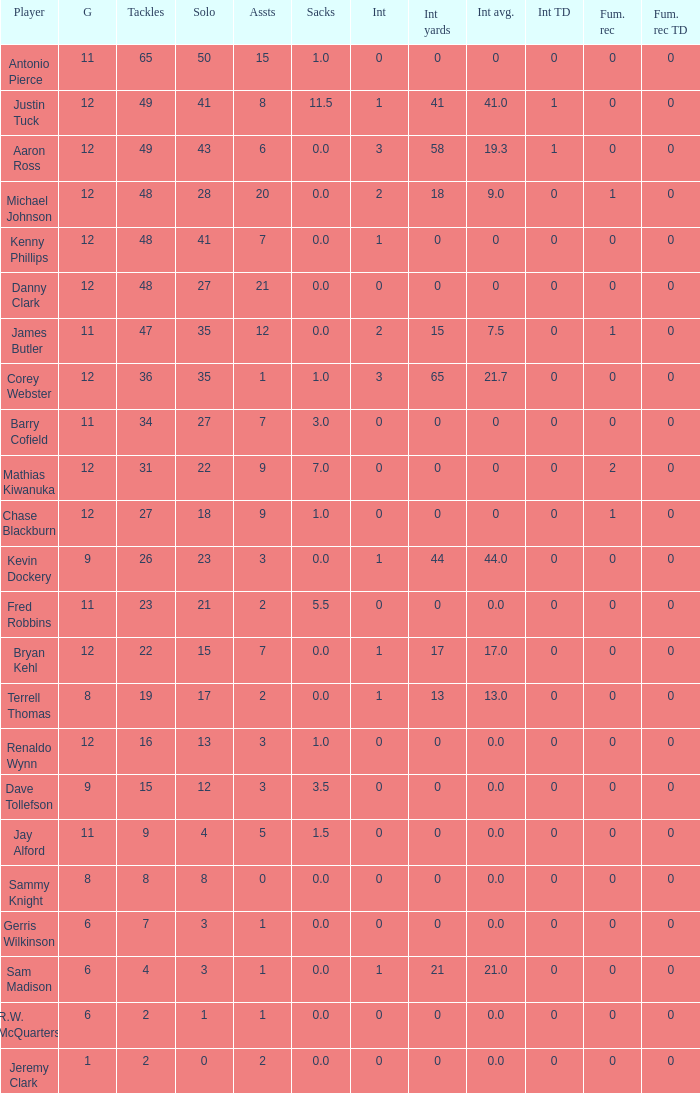What are the top tackles for 15.0. 